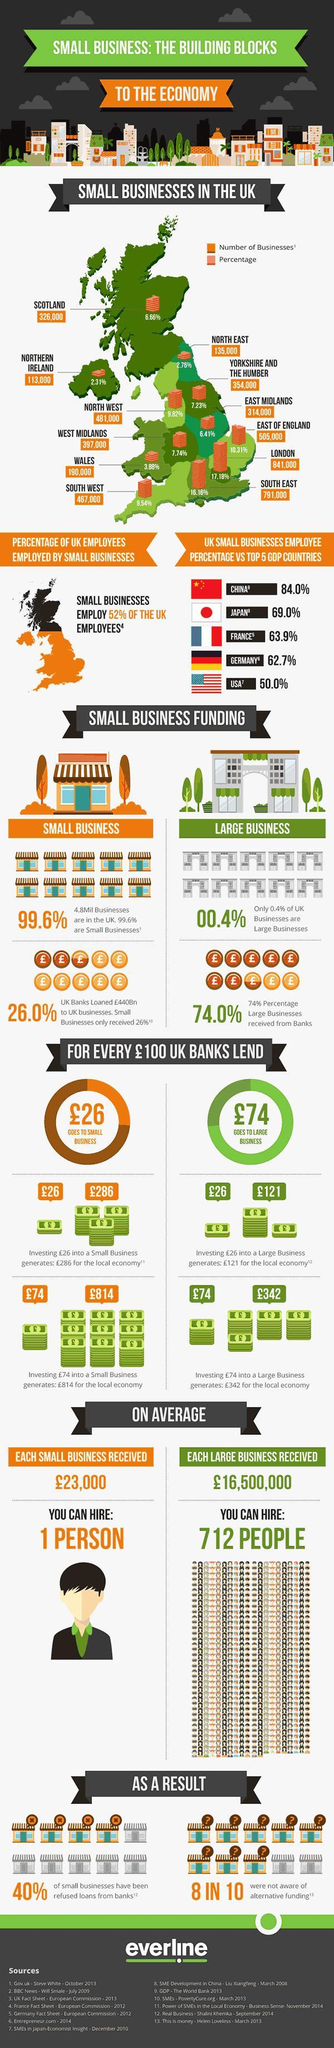How many businesses were aware of alternative funding?
Answer the question with a short phrase. 2 IN 10 Which area has the lowest percentage of small businesses? NORTHERN IRELAND Which area has the highest number of businesses? LONDON 